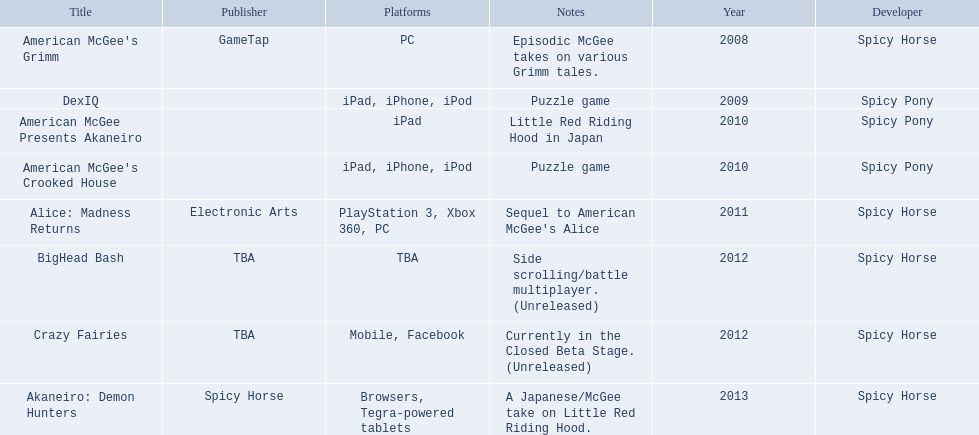What are all the titles? American McGee's Grimm, DexIQ, American McGee Presents Akaneiro, American McGee's Crooked House, Alice: Madness Returns, BigHead Bash, Crazy Fairies, Akaneiro: Demon Hunters. What platforms were they available on? PC, iPad, iPhone, iPod, iPad, iPad, iPhone, iPod, PlayStation 3, Xbox 360, PC, TBA, Mobile, Facebook, Browsers, Tegra-powered tablets. And which were available only on the ipad? American McGee Presents Akaneiro. 